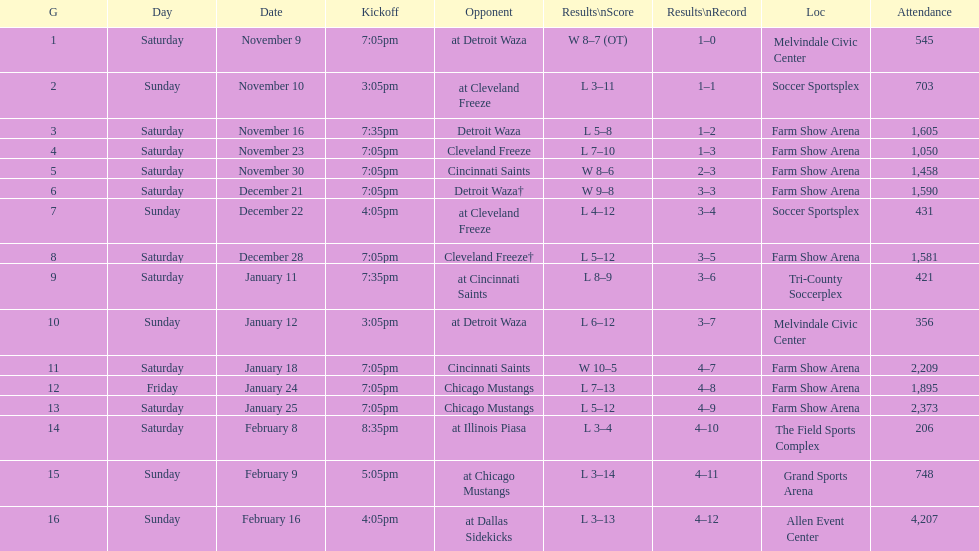Which opponent is listed first in the table? Detroit Waza. 